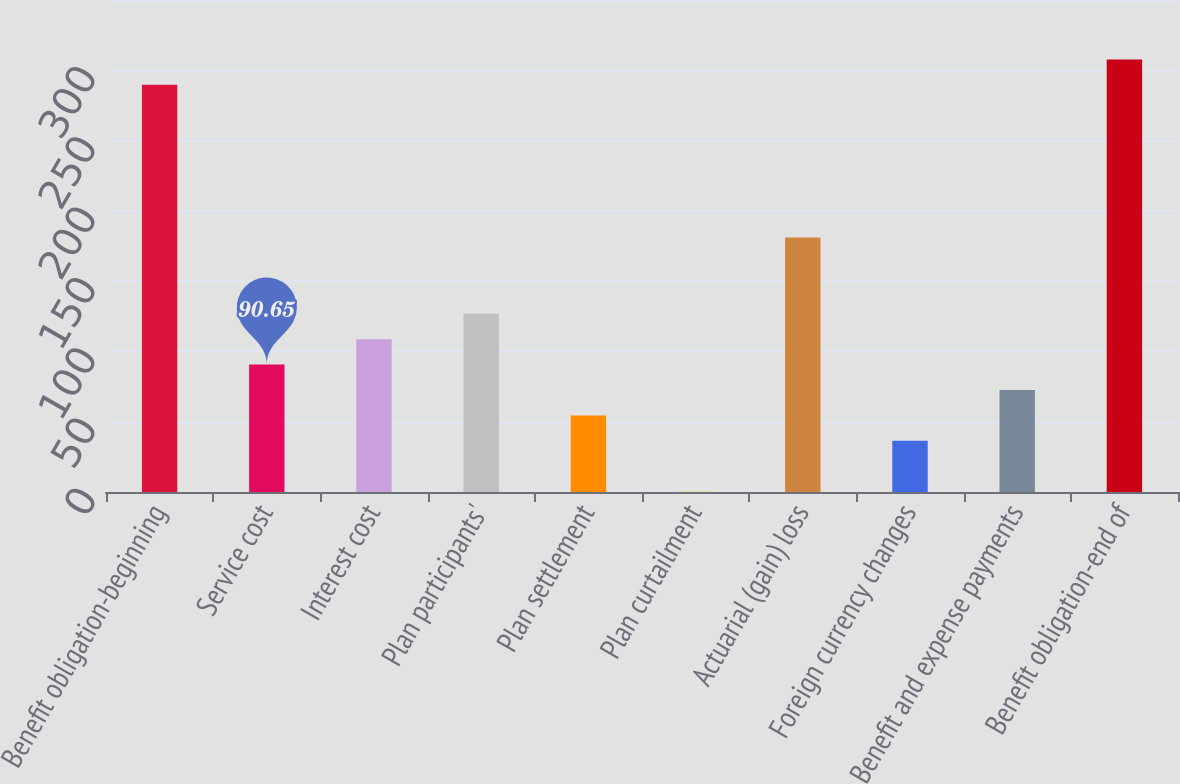Convert chart. <chart><loc_0><loc_0><loc_500><loc_500><bar_chart><fcel>Benefit obligation-beginning<fcel>Service cost<fcel>Interest cost<fcel>Plan participants'<fcel>Plan settlement<fcel>Plan curtailment<fcel>Actuarial (gain) loss<fcel>Foreign currency changes<fcel>Benefit and expense payments<fcel>Benefit obligation-end of<nl><fcel>289.64<fcel>90.65<fcel>108.74<fcel>126.83<fcel>54.47<fcel>0.2<fcel>181.1<fcel>36.38<fcel>72.56<fcel>307.73<nl></chart> 